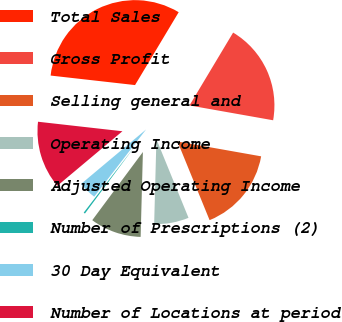Convert chart to OTSL. <chart><loc_0><loc_0><loc_500><loc_500><pie_chart><fcel>Total Sales<fcel>Gross Profit<fcel>Selling general and<fcel>Operating Income<fcel>Adjusted Operating Income<fcel>Number of Prescriptions (2)<fcel>30 Day Equivalent<fcel>Number of Locations at period<nl><fcel>31.8%<fcel>19.2%<fcel>16.04%<fcel>6.59%<fcel>9.74%<fcel>0.29%<fcel>3.44%<fcel>12.89%<nl></chart> 